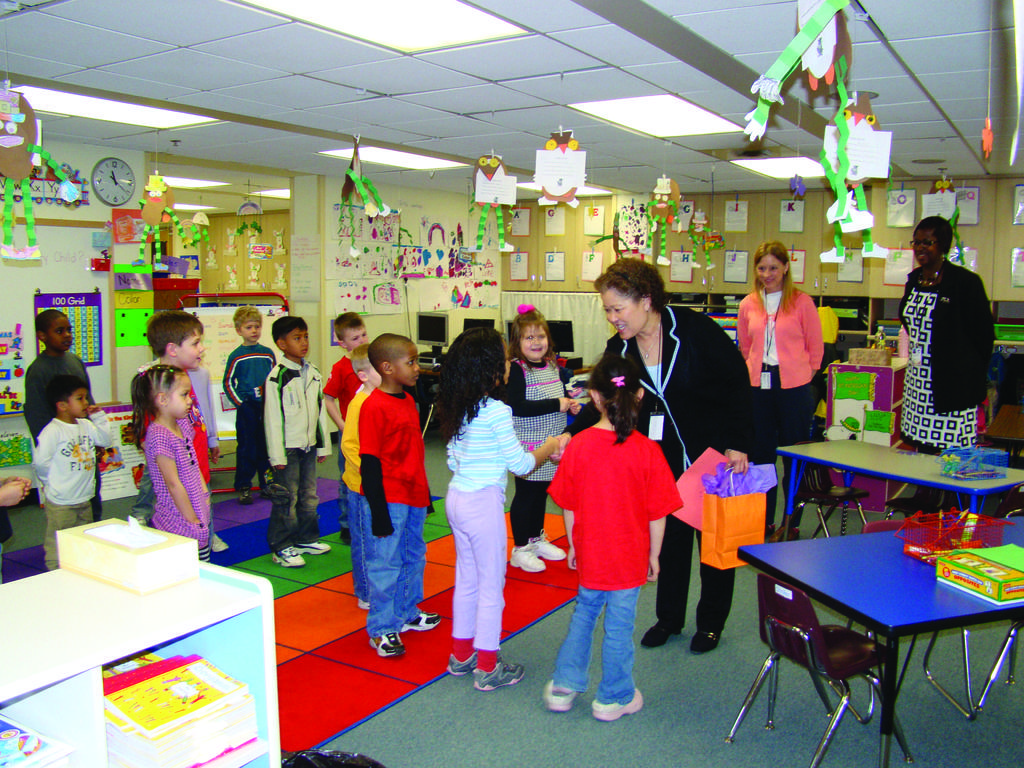In one or two sentences, can you explain what this image depicts? In this image i can see few children standing the woman standing here is talking with a child,there are two women standing here,in front of the women there is a table and a chair,there is a box on the table,at the back ground there are some papers attached to a wall,there is a clock on the wall,at the top there is a light. 